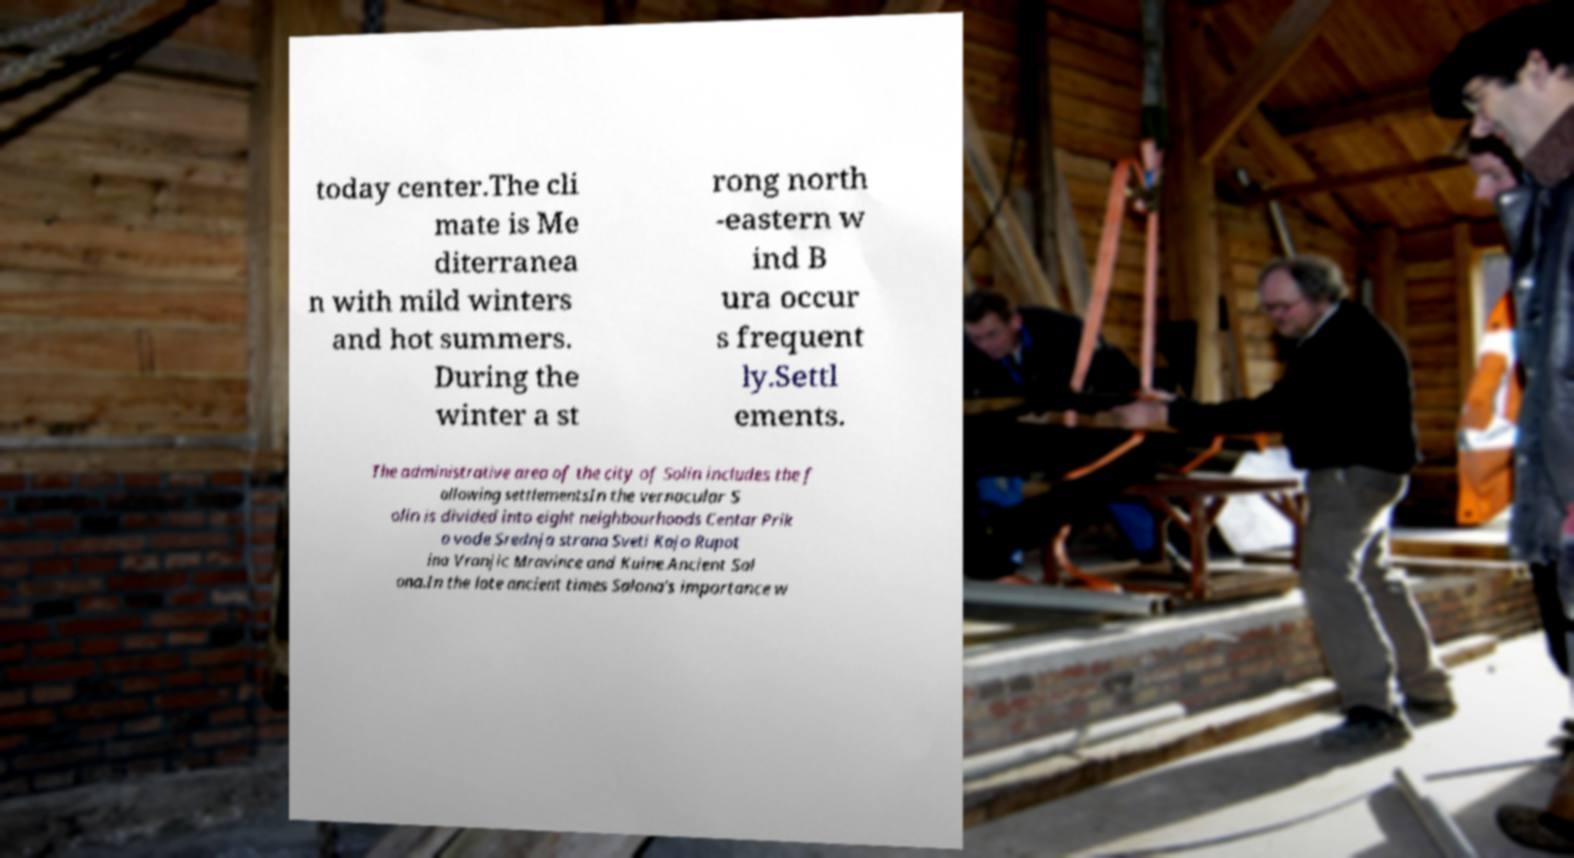Please identify and transcribe the text found in this image. today center.The cli mate is Me diterranea n with mild winters and hot summers. During the winter a st rong north -eastern w ind B ura occur s frequent ly.Settl ements. The administrative area of the city of Solin includes the f ollowing settlementsIn the vernacular S olin is divided into eight neighbourhoods Centar Prik o vode Srednja strana Sveti Kajo Rupot ina Vranjic Mravince and Kuine.Ancient Sal ona.In the late ancient times Salona's importance w 